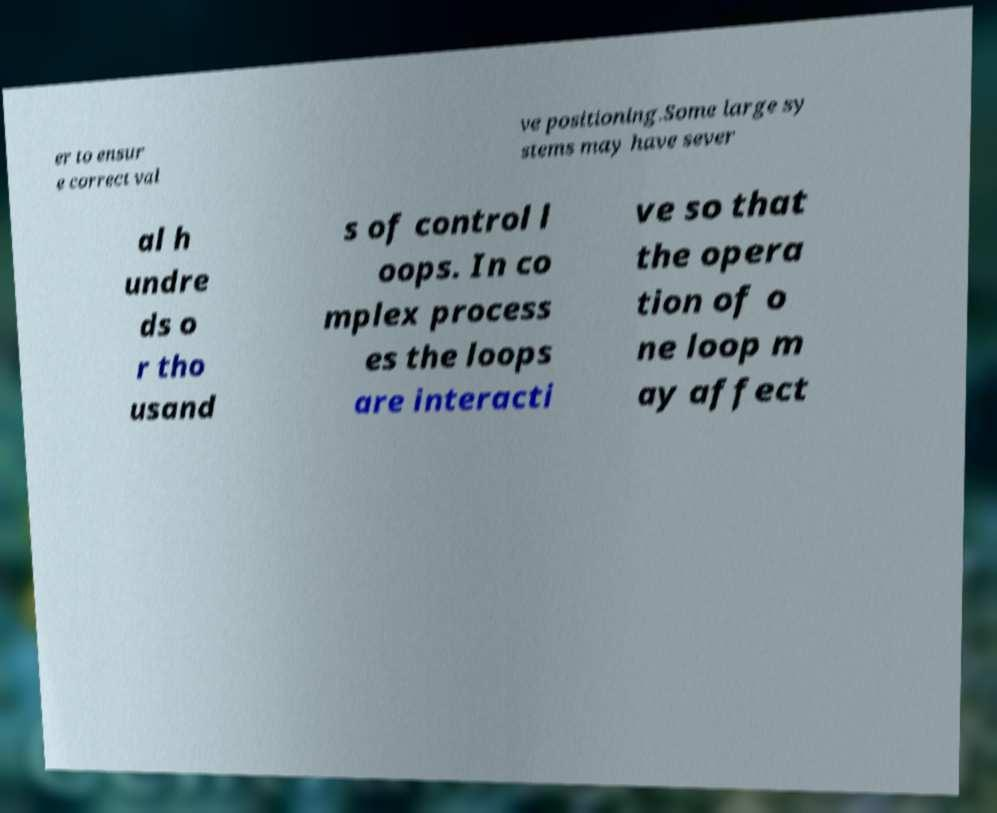Could you assist in decoding the text presented in this image and type it out clearly? er to ensur e correct val ve positioning.Some large sy stems may have sever al h undre ds o r tho usand s of control l oops. In co mplex process es the loops are interacti ve so that the opera tion of o ne loop m ay affect 